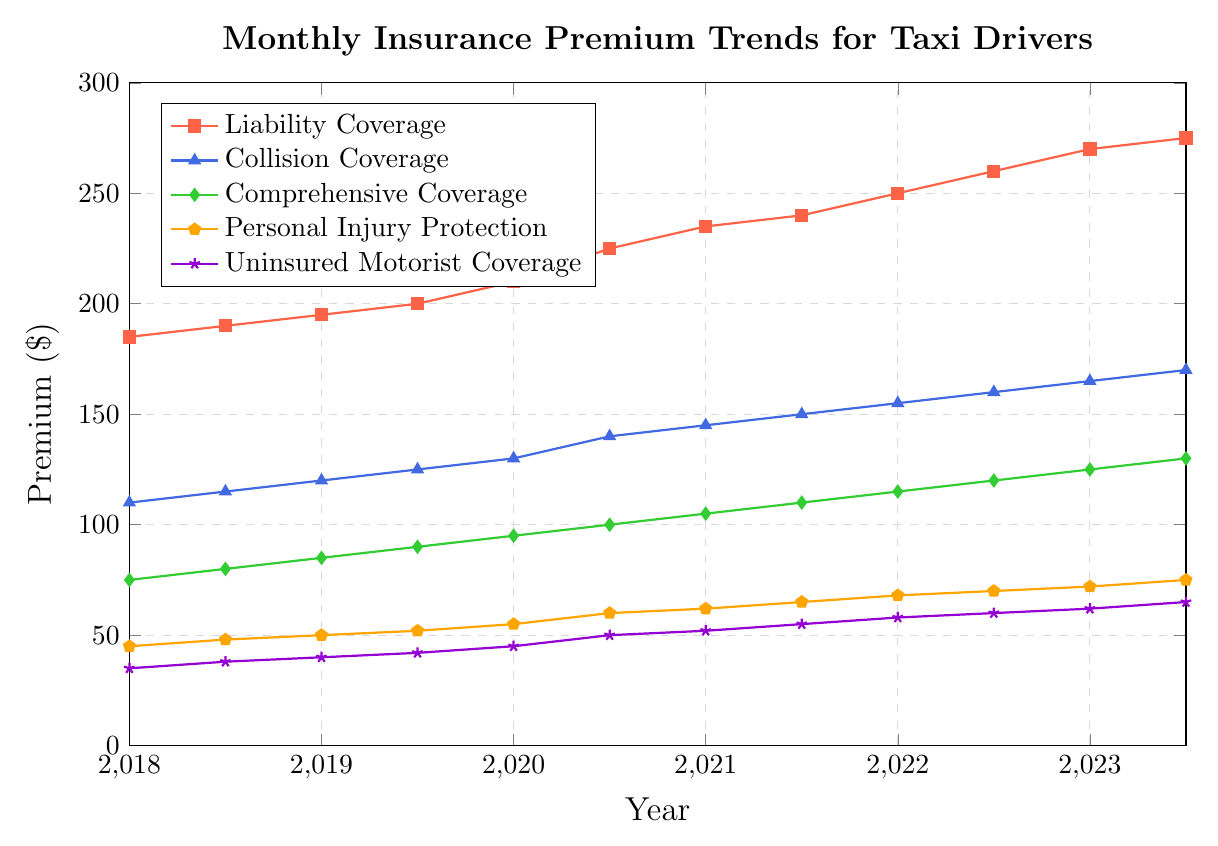What's the trend in the Liability Coverage premiums over the past 5 years? The premiums for Liability Coverage show a steady increase from $185 in January 2018 to $275 in July 2023. This indicates a consistent upward trend across the period.
Answer: Steady increase Which coverage type has the lowest premium throughout the period? Uninsured Motorist Coverage consistently has the lowest premium, starting at $35 in January 2018 and increasing to $65 in July 2023.
Answer: Uninsured Motorist Coverage What is the percentage increase in the Collision Coverage premium from January 2018 to July 2023? The premium increases from $110 in January 2018 to $170 in July 2023. The percentage increase is calculated as ((170 - 110) / 110) * 100.
Answer: 54.55% During which year did Personal Injury Protection see the highest increase in premiums? Personal Injury Protection premiums increased most significantly between July 2020 ($60) and January 2021 ($62), but the highest change occurred between July 2020 and January 2021 (from $60 to $62).
Answer: 2021 Compare the trends of Comprehensive Coverage and Collision Coverage. Which showed a greater total increase over the 5 years? Comprehensive Coverage increased from $75 in January 2018 to $130 in July 2023, a total increase of $55. Collision Coverage increased from $110 in January 2018 to $170 in July 2023, a total increase of $60. Therefore, Collision Coverage showed a greater total increase.
Answer: Collision Coverage How much more expensive is Liability Coverage than Comprehensive Coverage as of July 2023? In July 2023, Liability Coverage is $275, and Comprehensive Coverage is $130. The difference is $275 - $130.
Answer: $145 From 2018 to 2023, which coverage type shows the most variability in its premium? By examining the ranges, Liability Coverage shows the widest range, starting at $185 and ending at $275, indicating the most variability.
Answer: Liability Coverage What was the total premium paid for all types of coverage in January 2020? Summing the premiums in January 2020 for all types: Liability ($210), Collision ($130), Comprehensive ($95), Personal Injury Protection ($55), and Uninsured Motorist ($45) totals $535.
Answer: $535 